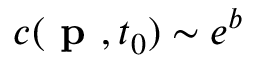Convert formula to latex. <formula><loc_0><loc_0><loc_500><loc_500>c ( p , t _ { 0 } ) \sim e ^ { b }</formula> 